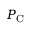Convert formula to latex. <formula><loc_0><loc_0><loc_500><loc_500>P _ { C }</formula> 